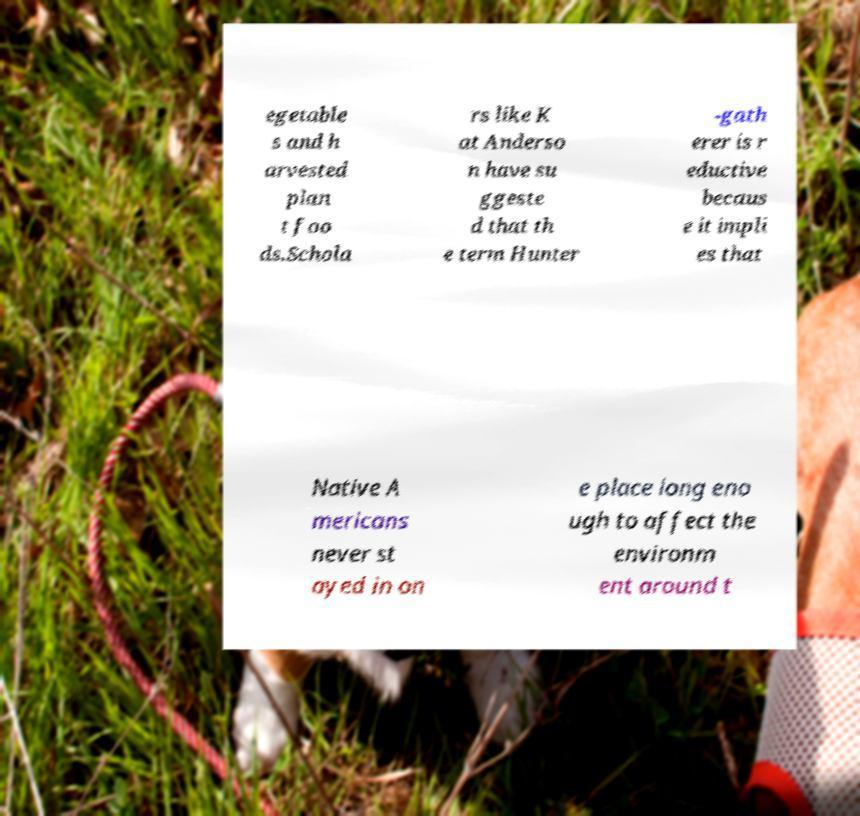Can you accurately transcribe the text from the provided image for me? egetable s and h arvested plan t foo ds.Schola rs like K at Anderso n have su ggeste d that th e term Hunter -gath erer is r eductive becaus e it impli es that Native A mericans never st ayed in on e place long eno ugh to affect the environm ent around t 